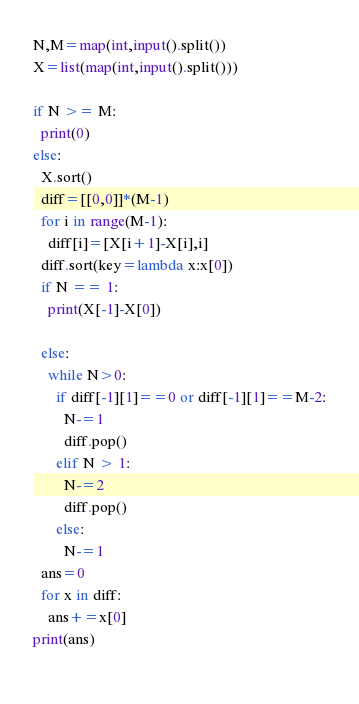<code> <loc_0><loc_0><loc_500><loc_500><_Python_>N,M=map(int,input().split())
X=list(map(int,input().split()))

if N >= M:
  print(0)
else:
  X.sort()
  diff=[[0,0]]*(M-1)
  for i in range(M-1):
    diff[i]=[X[i+1]-X[i],i]
  diff.sort(key=lambda x:x[0])
  if N == 1:
    print(X[-1]-X[0])
    
  else:
    while N>0:
      if diff[-1][1]==0 or diff[-1][1]==M-2:
        N-=1
        diff.pop()
      elif N > 1:
        N-=2
        diff.pop()
      else:
        N-=1
  ans=0
  for x in diff:
    ans+=x[0]
print(ans)
        </code> 